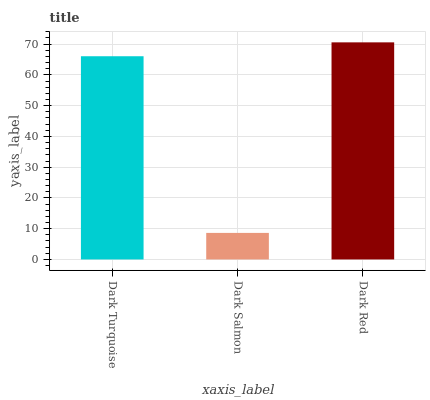Is Dark Salmon the minimum?
Answer yes or no. Yes. Is Dark Red the maximum?
Answer yes or no. Yes. Is Dark Red the minimum?
Answer yes or no. No. Is Dark Salmon the maximum?
Answer yes or no. No. Is Dark Red greater than Dark Salmon?
Answer yes or no. Yes. Is Dark Salmon less than Dark Red?
Answer yes or no. Yes. Is Dark Salmon greater than Dark Red?
Answer yes or no. No. Is Dark Red less than Dark Salmon?
Answer yes or no. No. Is Dark Turquoise the high median?
Answer yes or no. Yes. Is Dark Turquoise the low median?
Answer yes or no. Yes. Is Dark Red the high median?
Answer yes or no. No. Is Dark Salmon the low median?
Answer yes or no. No. 